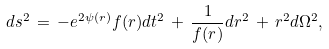<formula> <loc_0><loc_0><loc_500><loc_500>d s ^ { 2 } \, = \, - e ^ { 2 \psi ( r ) } f ( r ) d t ^ { 2 } \, + \, \frac { 1 } { f ( r ) } d r ^ { 2 } \, + \, r ^ { 2 } d \Omega ^ { 2 } ,</formula> 